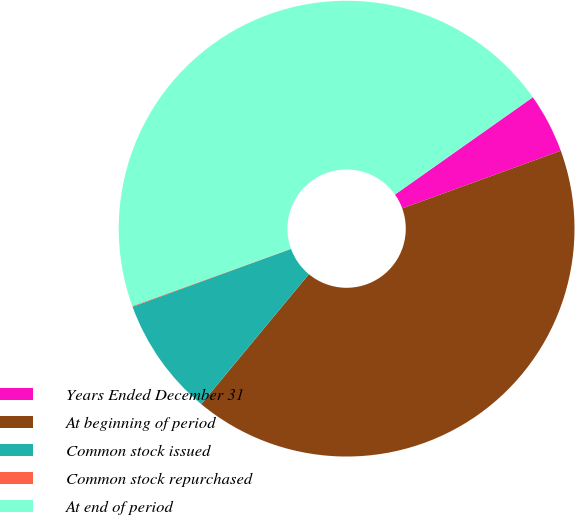<chart> <loc_0><loc_0><loc_500><loc_500><pie_chart><fcel>Years Ended December 31<fcel>At beginning of period<fcel>Common stock issued<fcel>Common stock repurchased<fcel>At end of period<nl><fcel>4.23%<fcel>41.56%<fcel>8.42%<fcel>0.05%<fcel>45.74%<nl></chart> 